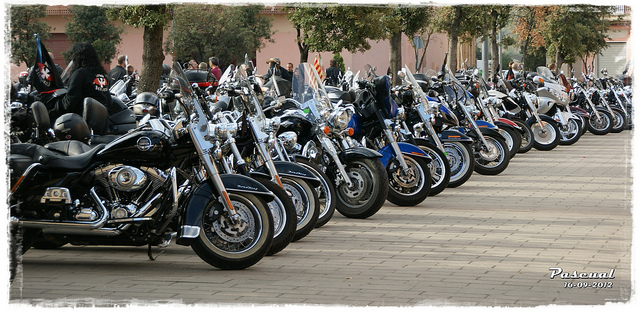Identify and read out the text in this image. 11-09-2012 Pascual 